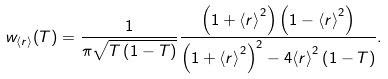Convert formula to latex. <formula><loc_0><loc_0><loc_500><loc_500>w _ { \langle r \rangle } ( T ) = \frac { 1 } { \pi \sqrt { T \left ( 1 - T \right ) } } \frac { \left ( 1 + { \langle r \rangle } ^ { 2 } \right ) \left ( 1 - { \langle r \rangle } ^ { 2 } \right ) } { \left ( 1 + { \langle r \rangle } ^ { 2 } \right ) ^ { 2 } - 4 { \langle r \rangle } ^ { 2 } \left ( 1 - T \right ) } .</formula> 